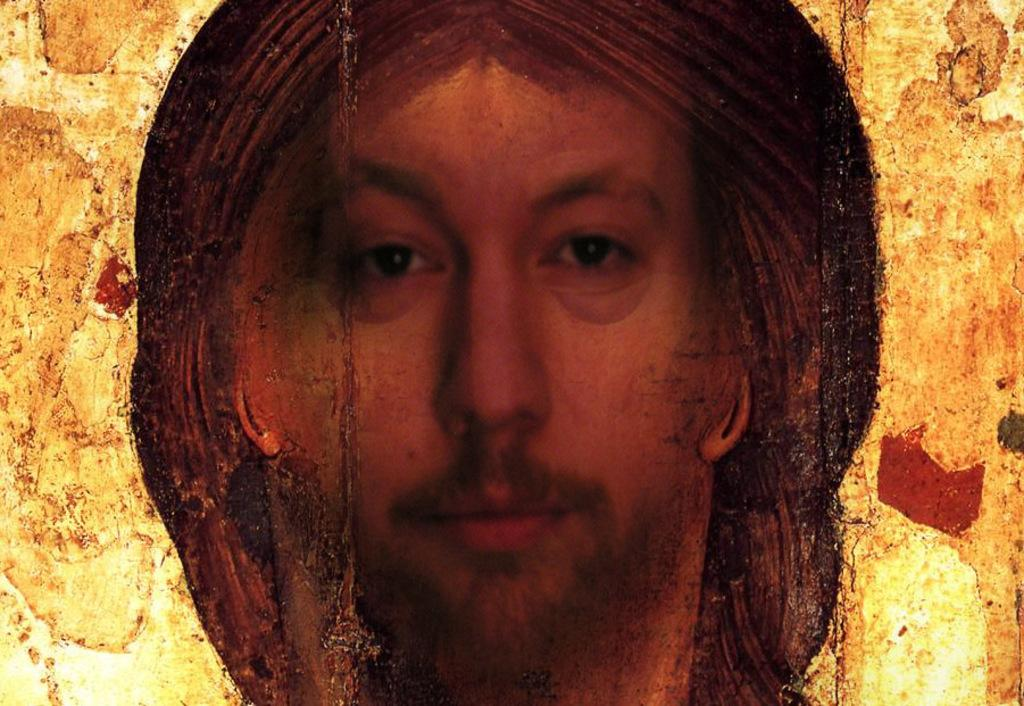What is the main subject of the image? There is a painting in the image. What does the painting depict? The painting depicts a person. Where is the painting located? The painting is on a wall. What type of engine can be seen in the painting? There is no engine present in the painting; it depicts a person. Is there a recess in the wall where the painting is located? The provided facts do not mention a recess in the wall, so we cannot determine its presence from the image. 